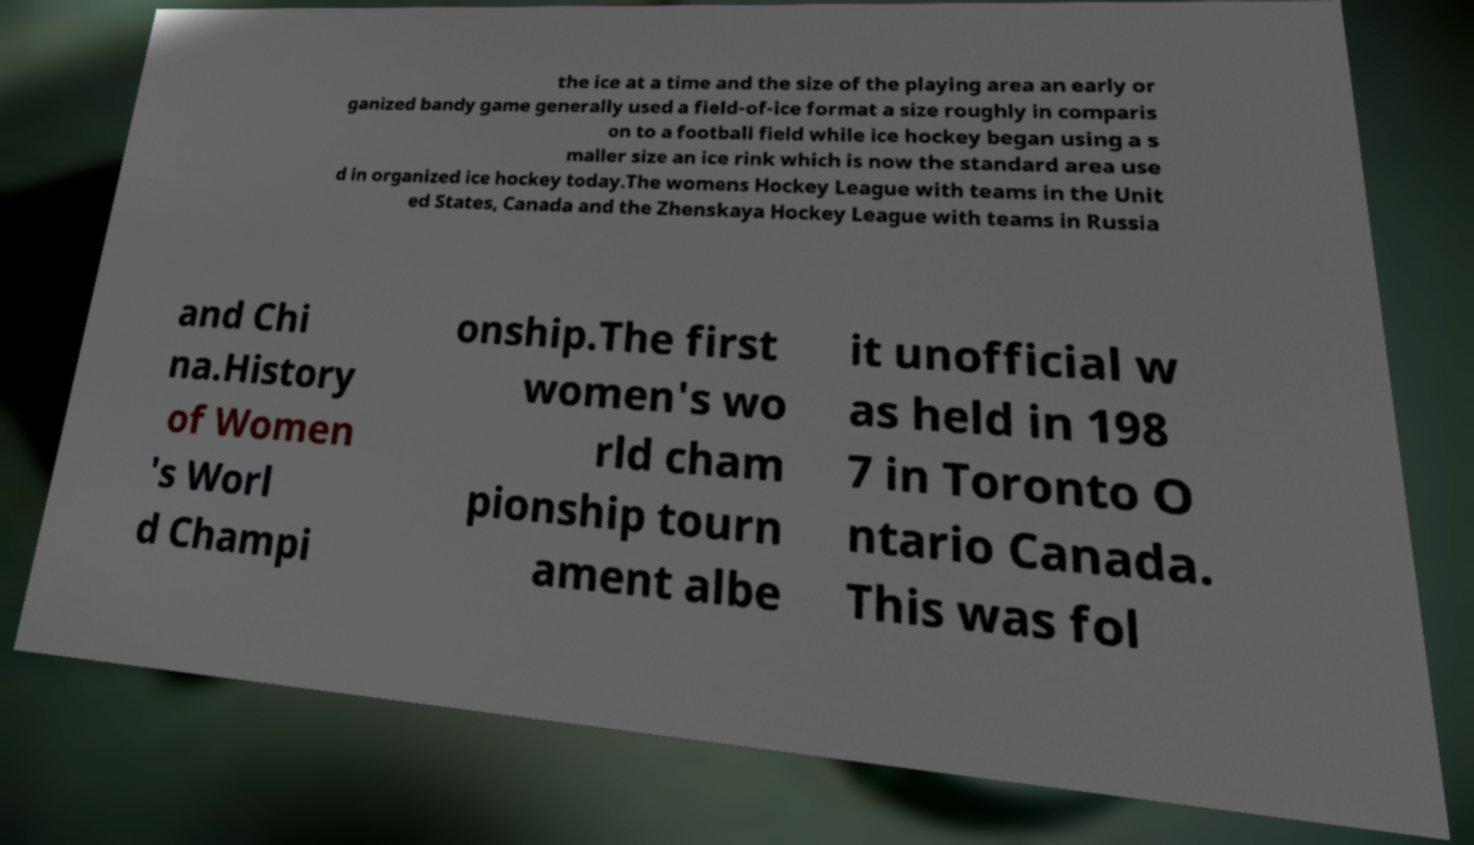Could you assist in decoding the text presented in this image and type it out clearly? the ice at a time and the size of the playing area an early or ganized bandy game generally used a field-of-ice format a size roughly in comparis on to a football field while ice hockey began using a s maller size an ice rink which is now the standard area use d in organized ice hockey today.The womens Hockey League with teams in the Unit ed States, Canada and the Zhenskaya Hockey League with teams in Russia and Chi na.History of Women 's Worl d Champi onship.The first women's wo rld cham pionship tourn ament albe it unofficial w as held in 198 7 in Toronto O ntario Canada. This was fol 